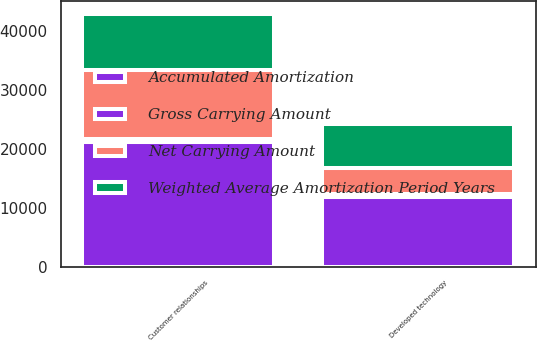<chart> <loc_0><loc_0><loc_500><loc_500><stacked_bar_chart><ecel><fcel>Developed technology<fcel>Customer relationships<nl><fcel>Gross Carrying Amount<fcel>510<fcel>510<nl><fcel>Accumulated Amortization<fcel>11850<fcel>21210<nl><fcel>Weighted Average Amortization Period Years<fcel>7533<fcel>9650<nl><fcel>Net Carrying Amount<fcel>4317<fcel>11560<nl></chart> 